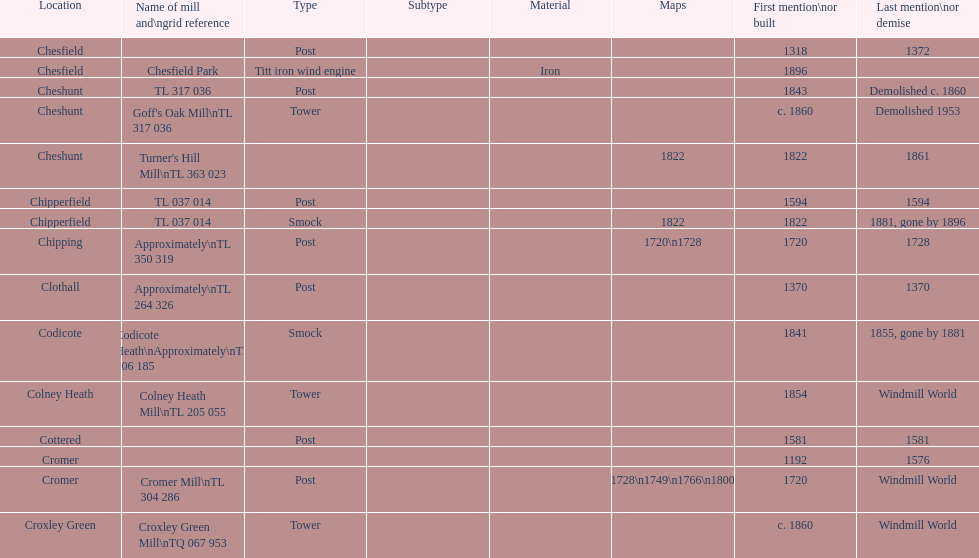What is the name of the only "c" mill located in colney health? Colney Heath Mill. 